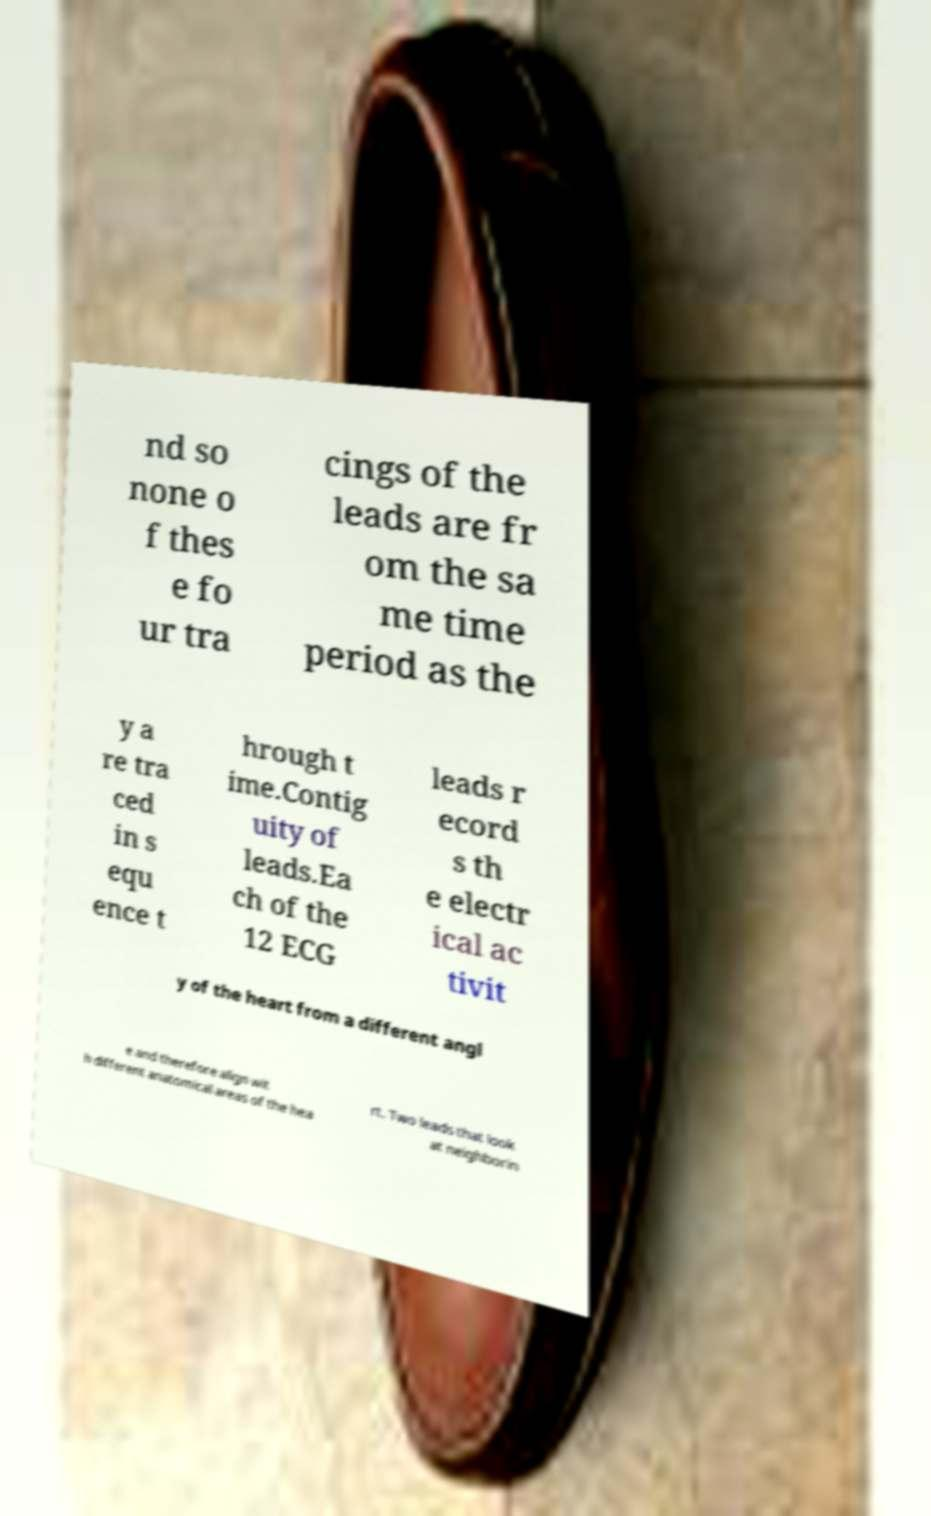Could you extract and type out the text from this image? nd so none o f thes e fo ur tra cings of the leads are fr om the sa me time period as the y a re tra ced in s equ ence t hrough t ime.Contig uity of leads.Ea ch of the 12 ECG leads r ecord s th e electr ical ac tivit y of the heart from a different angl e and therefore align wit h different anatomical areas of the hea rt. Two leads that look at neighborin 